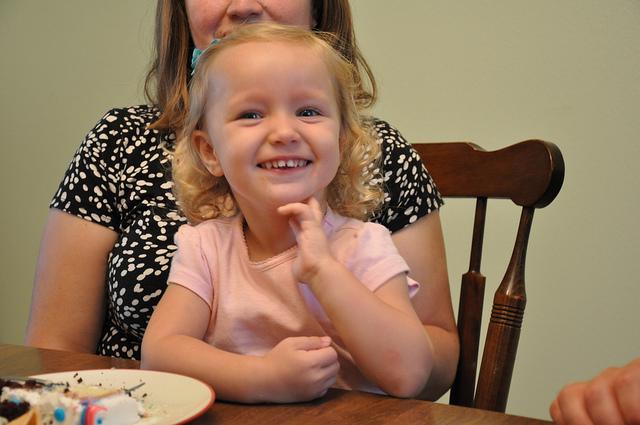Could this be her birthday?
Write a very short answer. Yes. Are both of these people female?
Write a very short answer. Yes. What facial expression does the girl have?
Keep it brief. Smile. 